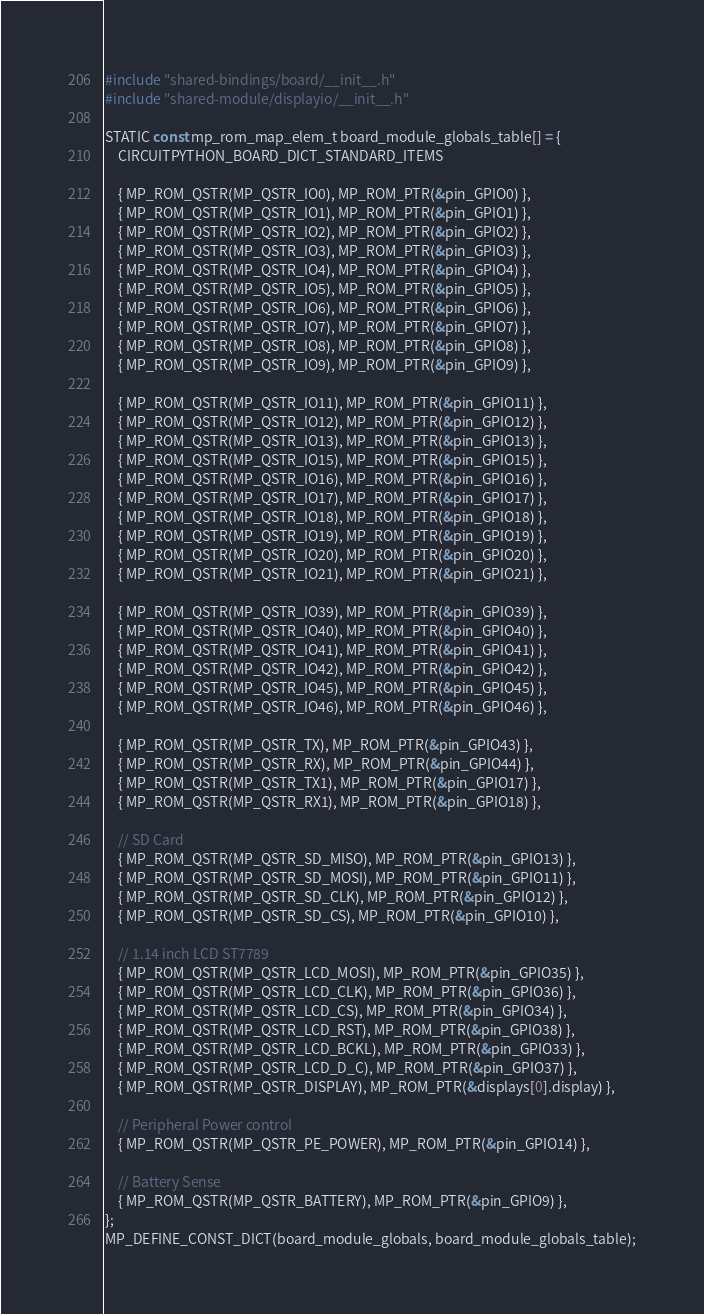Convert code to text. <code><loc_0><loc_0><loc_500><loc_500><_C_>#include "shared-bindings/board/__init__.h"
#include "shared-module/displayio/__init__.h"

STATIC const mp_rom_map_elem_t board_module_globals_table[] = {
    CIRCUITPYTHON_BOARD_DICT_STANDARD_ITEMS

    { MP_ROM_QSTR(MP_QSTR_IO0), MP_ROM_PTR(&pin_GPIO0) },
    { MP_ROM_QSTR(MP_QSTR_IO1), MP_ROM_PTR(&pin_GPIO1) },
    { MP_ROM_QSTR(MP_QSTR_IO2), MP_ROM_PTR(&pin_GPIO2) },
    { MP_ROM_QSTR(MP_QSTR_IO3), MP_ROM_PTR(&pin_GPIO3) },
    { MP_ROM_QSTR(MP_QSTR_IO4), MP_ROM_PTR(&pin_GPIO4) },
    { MP_ROM_QSTR(MP_QSTR_IO5), MP_ROM_PTR(&pin_GPIO5) },
    { MP_ROM_QSTR(MP_QSTR_IO6), MP_ROM_PTR(&pin_GPIO6) },
    { MP_ROM_QSTR(MP_QSTR_IO7), MP_ROM_PTR(&pin_GPIO7) },
    { MP_ROM_QSTR(MP_QSTR_IO8), MP_ROM_PTR(&pin_GPIO8) },
    { MP_ROM_QSTR(MP_QSTR_IO9), MP_ROM_PTR(&pin_GPIO9) },

    { MP_ROM_QSTR(MP_QSTR_IO11), MP_ROM_PTR(&pin_GPIO11) },
    { MP_ROM_QSTR(MP_QSTR_IO12), MP_ROM_PTR(&pin_GPIO12) },
    { MP_ROM_QSTR(MP_QSTR_IO13), MP_ROM_PTR(&pin_GPIO13) },
    { MP_ROM_QSTR(MP_QSTR_IO15), MP_ROM_PTR(&pin_GPIO15) },
    { MP_ROM_QSTR(MP_QSTR_IO16), MP_ROM_PTR(&pin_GPIO16) },
    { MP_ROM_QSTR(MP_QSTR_IO17), MP_ROM_PTR(&pin_GPIO17) },
    { MP_ROM_QSTR(MP_QSTR_IO18), MP_ROM_PTR(&pin_GPIO18) },
    { MP_ROM_QSTR(MP_QSTR_IO19), MP_ROM_PTR(&pin_GPIO19) },
    { MP_ROM_QSTR(MP_QSTR_IO20), MP_ROM_PTR(&pin_GPIO20) },
    { MP_ROM_QSTR(MP_QSTR_IO21), MP_ROM_PTR(&pin_GPIO21) },

    { MP_ROM_QSTR(MP_QSTR_IO39), MP_ROM_PTR(&pin_GPIO39) },
    { MP_ROM_QSTR(MP_QSTR_IO40), MP_ROM_PTR(&pin_GPIO40) },
    { MP_ROM_QSTR(MP_QSTR_IO41), MP_ROM_PTR(&pin_GPIO41) },
    { MP_ROM_QSTR(MP_QSTR_IO42), MP_ROM_PTR(&pin_GPIO42) },
    { MP_ROM_QSTR(MP_QSTR_IO45), MP_ROM_PTR(&pin_GPIO45) },
    { MP_ROM_QSTR(MP_QSTR_IO46), MP_ROM_PTR(&pin_GPIO46) },

    { MP_ROM_QSTR(MP_QSTR_TX), MP_ROM_PTR(&pin_GPIO43) },
    { MP_ROM_QSTR(MP_QSTR_RX), MP_ROM_PTR(&pin_GPIO44) },
    { MP_ROM_QSTR(MP_QSTR_TX1), MP_ROM_PTR(&pin_GPIO17) },
    { MP_ROM_QSTR(MP_QSTR_RX1), MP_ROM_PTR(&pin_GPIO18) },

    // SD Card
    { MP_ROM_QSTR(MP_QSTR_SD_MISO), MP_ROM_PTR(&pin_GPIO13) },
    { MP_ROM_QSTR(MP_QSTR_SD_MOSI), MP_ROM_PTR(&pin_GPIO11) },
    { MP_ROM_QSTR(MP_QSTR_SD_CLK), MP_ROM_PTR(&pin_GPIO12) },
    { MP_ROM_QSTR(MP_QSTR_SD_CS), MP_ROM_PTR(&pin_GPIO10) },

    // 1.14 inch LCD ST7789
    { MP_ROM_QSTR(MP_QSTR_LCD_MOSI), MP_ROM_PTR(&pin_GPIO35) },
    { MP_ROM_QSTR(MP_QSTR_LCD_CLK), MP_ROM_PTR(&pin_GPIO36) },
    { MP_ROM_QSTR(MP_QSTR_LCD_CS), MP_ROM_PTR(&pin_GPIO34) },
    { MP_ROM_QSTR(MP_QSTR_LCD_RST), MP_ROM_PTR(&pin_GPIO38) },
    { MP_ROM_QSTR(MP_QSTR_LCD_BCKL), MP_ROM_PTR(&pin_GPIO33) },
    { MP_ROM_QSTR(MP_QSTR_LCD_D_C), MP_ROM_PTR(&pin_GPIO37) },
    { MP_ROM_QSTR(MP_QSTR_DISPLAY), MP_ROM_PTR(&displays[0].display) },

    // Peripheral Power control
    { MP_ROM_QSTR(MP_QSTR_PE_POWER), MP_ROM_PTR(&pin_GPIO14) },

    // Battery Sense
    { MP_ROM_QSTR(MP_QSTR_BATTERY), MP_ROM_PTR(&pin_GPIO9) },
};
MP_DEFINE_CONST_DICT(board_module_globals, board_module_globals_table);
</code> 